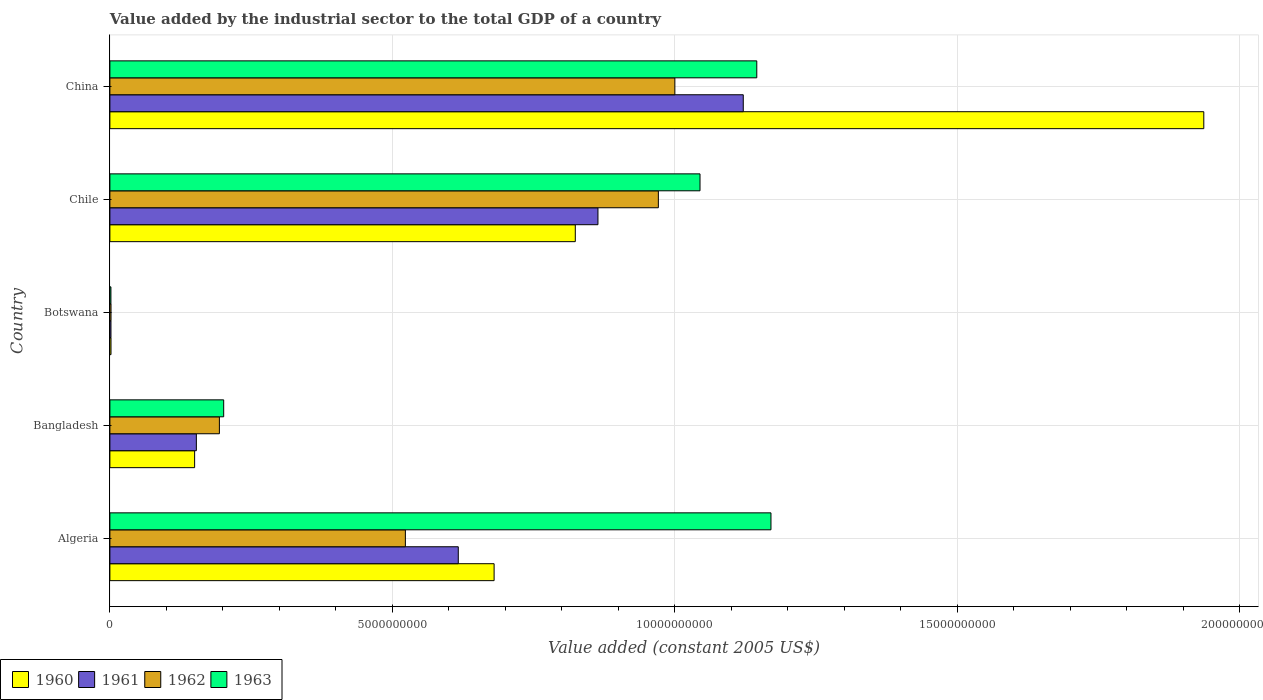How many different coloured bars are there?
Your answer should be compact. 4. Are the number of bars per tick equal to the number of legend labels?
Make the answer very short. Yes. How many bars are there on the 5th tick from the top?
Provide a succinct answer. 4. What is the label of the 2nd group of bars from the top?
Keep it short and to the point. Chile. What is the value added by the industrial sector in 1962 in Chile?
Provide a short and direct response. 9.71e+09. Across all countries, what is the maximum value added by the industrial sector in 1960?
Your response must be concise. 1.94e+1. Across all countries, what is the minimum value added by the industrial sector in 1963?
Make the answer very short. 1.83e+07. In which country was the value added by the industrial sector in 1961 maximum?
Make the answer very short. China. In which country was the value added by the industrial sector in 1963 minimum?
Your response must be concise. Botswana. What is the total value added by the industrial sector in 1961 in the graph?
Provide a short and direct response. 2.76e+1. What is the difference between the value added by the industrial sector in 1960 in Bangladesh and that in Chile?
Provide a short and direct response. -6.74e+09. What is the difference between the value added by the industrial sector in 1961 in Bangladesh and the value added by the industrial sector in 1963 in Chile?
Provide a succinct answer. -8.92e+09. What is the average value added by the industrial sector in 1963 per country?
Ensure brevity in your answer.  7.13e+09. What is the difference between the value added by the industrial sector in 1961 and value added by the industrial sector in 1960 in Algeria?
Your response must be concise. -6.34e+08. In how many countries, is the value added by the industrial sector in 1962 greater than 15000000000 US$?
Provide a short and direct response. 0. What is the ratio of the value added by the industrial sector in 1962 in Bangladesh to that in Botswana?
Provide a short and direct response. 97.78. Is the difference between the value added by the industrial sector in 1961 in Algeria and Botswana greater than the difference between the value added by the industrial sector in 1960 in Algeria and Botswana?
Provide a succinct answer. No. What is the difference between the highest and the second highest value added by the industrial sector in 1962?
Provide a short and direct response. 2.92e+08. What is the difference between the highest and the lowest value added by the industrial sector in 1962?
Provide a succinct answer. 9.98e+09. Is it the case that in every country, the sum of the value added by the industrial sector in 1961 and value added by the industrial sector in 1960 is greater than the value added by the industrial sector in 1963?
Keep it short and to the point. Yes. How many bars are there?
Your answer should be compact. 20. How many countries are there in the graph?
Make the answer very short. 5. What is the difference between two consecutive major ticks on the X-axis?
Ensure brevity in your answer.  5.00e+09. Does the graph contain any zero values?
Keep it short and to the point. No. Does the graph contain grids?
Ensure brevity in your answer.  Yes. Where does the legend appear in the graph?
Offer a terse response. Bottom left. How many legend labels are there?
Give a very brief answer. 4. What is the title of the graph?
Your response must be concise. Value added by the industrial sector to the total GDP of a country. What is the label or title of the X-axis?
Offer a terse response. Value added (constant 2005 US$). What is the Value added (constant 2005 US$) of 1960 in Algeria?
Keep it short and to the point. 6.80e+09. What is the Value added (constant 2005 US$) in 1961 in Algeria?
Ensure brevity in your answer.  6.17e+09. What is the Value added (constant 2005 US$) in 1962 in Algeria?
Provide a succinct answer. 5.23e+09. What is the Value added (constant 2005 US$) in 1963 in Algeria?
Give a very brief answer. 1.17e+1. What is the Value added (constant 2005 US$) in 1960 in Bangladesh?
Your answer should be compact. 1.50e+09. What is the Value added (constant 2005 US$) of 1961 in Bangladesh?
Provide a succinct answer. 1.53e+09. What is the Value added (constant 2005 US$) in 1962 in Bangladesh?
Make the answer very short. 1.94e+09. What is the Value added (constant 2005 US$) of 1963 in Bangladesh?
Provide a succinct answer. 2.01e+09. What is the Value added (constant 2005 US$) in 1960 in Botswana?
Offer a terse response. 1.96e+07. What is the Value added (constant 2005 US$) of 1961 in Botswana?
Give a very brief answer. 1.92e+07. What is the Value added (constant 2005 US$) of 1962 in Botswana?
Provide a succinct answer. 1.98e+07. What is the Value added (constant 2005 US$) in 1963 in Botswana?
Keep it short and to the point. 1.83e+07. What is the Value added (constant 2005 US$) of 1960 in Chile?
Make the answer very short. 8.24e+09. What is the Value added (constant 2005 US$) in 1961 in Chile?
Make the answer very short. 8.64e+09. What is the Value added (constant 2005 US$) of 1962 in Chile?
Your answer should be compact. 9.71e+09. What is the Value added (constant 2005 US$) in 1963 in Chile?
Offer a terse response. 1.04e+1. What is the Value added (constant 2005 US$) of 1960 in China?
Provide a short and direct response. 1.94e+1. What is the Value added (constant 2005 US$) of 1961 in China?
Your answer should be compact. 1.12e+1. What is the Value added (constant 2005 US$) in 1962 in China?
Provide a succinct answer. 1.00e+1. What is the Value added (constant 2005 US$) of 1963 in China?
Provide a succinct answer. 1.15e+1. Across all countries, what is the maximum Value added (constant 2005 US$) in 1960?
Your answer should be very brief. 1.94e+1. Across all countries, what is the maximum Value added (constant 2005 US$) in 1961?
Keep it short and to the point. 1.12e+1. Across all countries, what is the maximum Value added (constant 2005 US$) in 1962?
Offer a very short reply. 1.00e+1. Across all countries, what is the maximum Value added (constant 2005 US$) in 1963?
Keep it short and to the point. 1.17e+1. Across all countries, what is the minimum Value added (constant 2005 US$) of 1960?
Offer a terse response. 1.96e+07. Across all countries, what is the minimum Value added (constant 2005 US$) of 1961?
Provide a short and direct response. 1.92e+07. Across all countries, what is the minimum Value added (constant 2005 US$) in 1962?
Offer a terse response. 1.98e+07. Across all countries, what is the minimum Value added (constant 2005 US$) of 1963?
Offer a terse response. 1.83e+07. What is the total Value added (constant 2005 US$) of 1960 in the graph?
Your answer should be very brief. 3.59e+1. What is the total Value added (constant 2005 US$) in 1961 in the graph?
Your answer should be very brief. 2.76e+1. What is the total Value added (constant 2005 US$) in 1962 in the graph?
Offer a terse response. 2.69e+1. What is the total Value added (constant 2005 US$) in 1963 in the graph?
Your answer should be compact. 3.56e+1. What is the difference between the Value added (constant 2005 US$) of 1960 in Algeria and that in Bangladesh?
Your answer should be compact. 5.30e+09. What is the difference between the Value added (constant 2005 US$) of 1961 in Algeria and that in Bangladesh?
Give a very brief answer. 4.64e+09. What is the difference between the Value added (constant 2005 US$) of 1962 in Algeria and that in Bangladesh?
Your response must be concise. 3.29e+09. What is the difference between the Value added (constant 2005 US$) of 1963 in Algeria and that in Bangladesh?
Provide a short and direct response. 9.69e+09. What is the difference between the Value added (constant 2005 US$) in 1960 in Algeria and that in Botswana?
Your response must be concise. 6.78e+09. What is the difference between the Value added (constant 2005 US$) of 1961 in Algeria and that in Botswana?
Make the answer very short. 6.15e+09. What is the difference between the Value added (constant 2005 US$) in 1962 in Algeria and that in Botswana?
Offer a very short reply. 5.21e+09. What is the difference between the Value added (constant 2005 US$) of 1963 in Algeria and that in Botswana?
Offer a very short reply. 1.17e+1. What is the difference between the Value added (constant 2005 US$) of 1960 in Algeria and that in Chile?
Provide a succinct answer. -1.44e+09. What is the difference between the Value added (constant 2005 US$) of 1961 in Algeria and that in Chile?
Give a very brief answer. -2.47e+09. What is the difference between the Value added (constant 2005 US$) in 1962 in Algeria and that in Chile?
Give a very brief answer. -4.48e+09. What is the difference between the Value added (constant 2005 US$) in 1963 in Algeria and that in Chile?
Give a very brief answer. 1.26e+09. What is the difference between the Value added (constant 2005 US$) in 1960 in Algeria and that in China?
Offer a very short reply. -1.26e+1. What is the difference between the Value added (constant 2005 US$) in 1961 in Algeria and that in China?
Make the answer very short. -5.05e+09. What is the difference between the Value added (constant 2005 US$) of 1962 in Algeria and that in China?
Provide a succinct answer. -4.77e+09. What is the difference between the Value added (constant 2005 US$) in 1963 in Algeria and that in China?
Give a very brief answer. 2.51e+08. What is the difference between the Value added (constant 2005 US$) of 1960 in Bangladesh and that in Botswana?
Provide a short and direct response. 1.48e+09. What is the difference between the Value added (constant 2005 US$) of 1961 in Bangladesh and that in Botswana?
Offer a terse response. 1.51e+09. What is the difference between the Value added (constant 2005 US$) in 1962 in Bangladesh and that in Botswana?
Give a very brief answer. 1.92e+09. What is the difference between the Value added (constant 2005 US$) in 1963 in Bangladesh and that in Botswana?
Ensure brevity in your answer.  2.00e+09. What is the difference between the Value added (constant 2005 US$) of 1960 in Bangladesh and that in Chile?
Provide a succinct answer. -6.74e+09. What is the difference between the Value added (constant 2005 US$) of 1961 in Bangladesh and that in Chile?
Provide a succinct answer. -7.11e+09. What is the difference between the Value added (constant 2005 US$) of 1962 in Bangladesh and that in Chile?
Your answer should be very brief. -7.77e+09. What is the difference between the Value added (constant 2005 US$) in 1963 in Bangladesh and that in Chile?
Provide a short and direct response. -8.43e+09. What is the difference between the Value added (constant 2005 US$) of 1960 in Bangladesh and that in China?
Provide a short and direct response. -1.79e+1. What is the difference between the Value added (constant 2005 US$) in 1961 in Bangladesh and that in China?
Your answer should be compact. -9.68e+09. What is the difference between the Value added (constant 2005 US$) of 1962 in Bangladesh and that in China?
Keep it short and to the point. -8.06e+09. What is the difference between the Value added (constant 2005 US$) of 1963 in Bangladesh and that in China?
Your answer should be compact. -9.44e+09. What is the difference between the Value added (constant 2005 US$) in 1960 in Botswana and that in Chile?
Provide a short and direct response. -8.22e+09. What is the difference between the Value added (constant 2005 US$) in 1961 in Botswana and that in Chile?
Provide a succinct answer. -8.62e+09. What is the difference between the Value added (constant 2005 US$) in 1962 in Botswana and that in Chile?
Provide a succinct answer. -9.69e+09. What is the difference between the Value added (constant 2005 US$) in 1963 in Botswana and that in Chile?
Your answer should be compact. -1.04e+1. What is the difference between the Value added (constant 2005 US$) in 1960 in Botswana and that in China?
Give a very brief answer. -1.93e+1. What is the difference between the Value added (constant 2005 US$) in 1961 in Botswana and that in China?
Provide a short and direct response. -1.12e+1. What is the difference between the Value added (constant 2005 US$) in 1962 in Botswana and that in China?
Make the answer very short. -9.98e+09. What is the difference between the Value added (constant 2005 US$) in 1963 in Botswana and that in China?
Your response must be concise. -1.14e+1. What is the difference between the Value added (constant 2005 US$) of 1960 in Chile and that in China?
Offer a very short reply. -1.11e+1. What is the difference between the Value added (constant 2005 US$) of 1961 in Chile and that in China?
Your answer should be compact. -2.57e+09. What is the difference between the Value added (constant 2005 US$) in 1962 in Chile and that in China?
Your answer should be very brief. -2.92e+08. What is the difference between the Value added (constant 2005 US$) of 1963 in Chile and that in China?
Offer a very short reply. -1.01e+09. What is the difference between the Value added (constant 2005 US$) of 1960 in Algeria and the Value added (constant 2005 US$) of 1961 in Bangladesh?
Give a very brief answer. 5.27e+09. What is the difference between the Value added (constant 2005 US$) of 1960 in Algeria and the Value added (constant 2005 US$) of 1962 in Bangladesh?
Keep it short and to the point. 4.86e+09. What is the difference between the Value added (constant 2005 US$) of 1960 in Algeria and the Value added (constant 2005 US$) of 1963 in Bangladesh?
Provide a short and direct response. 4.79e+09. What is the difference between the Value added (constant 2005 US$) in 1961 in Algeria and the Value added (constant 2005 US$) in 1962 in Bangladesh?
Provide a short and direct response. 4.23e+09. What is the difference between the Value added (constant 2005 US$) of 1961 in Algeria and the Value added (constant 2005 US$) of 1963 in Bangladesh?
Offer a terse response. 4.15e+09. What is the difference between the Value added (constant 2005 US$) of 1962 in Algeria and the Value added (constant 2005 US$) of 1963 in Bangladesh?
Provide a short and direct response. 3.22e+09. What is the difference between the Value added (constant 2005 US$) of 1960 in Algeria and the Value added (constant 2005 US$) of 1961 in Botswana?
Your response must be concise. 6.78e+09. What is the difference between the Value added (constant 2005 US$) in 1960 in Algeria and the Value added (constant 2005 US$) in 1962 in Botswana?
Your answer should be compact. 6.78e+09. What is the difference between the Value added (constant 2005 US$) of 1960 in Algeria and the Value added (constant 2005 US$) of 1963 in Botswana?
Provide a succinct answer. 6.78e+09. What is the difference between the Value added (constant 2005 US$) in 1961 in Algeria and the Value added (constant 2005 US$) in 1962 in Botswana?
Make the answer very short. 6.15e+09. What is the difference between the Value added (constant 2005 US$) in 1961 in Algeria and the Value added (constant 2005 US$) in 1963 in Botswana?
Offer a very short reply. 6.15e+09. What is the difference between the Value added (constant 2005 US$) in 1962 in Algeria and the Value added (constant 2005 US$) in 1963 in Botswana?
Provide a short and direct response. 5.21e+09. What is the difference between the Value added (constant 2005 US$) in 1960 in Algeria and the Value added (constant 2005 US$) in 1961 in Chile?
Your answer should be very brief. -1.84e+09. What is the difference between the Value added (constant 2005 US$) of 1960 in Algeria and the Value added (constant 2005 US$) of 1962 in Chile?
Offer a very short reply. -2.91e+09. What is the difference between the Value added (constant 2005 US$) of 1960 in Algeria and the Value added (constant 2005 US$) of 1963 in Chile?
Your answer should be very brief. -3.65e+09. What is the difference between the Value added (constant 2005 US$) in 1961 in Algeria and the Value added (constant 2005 US$) in 1962 in Chile?
Your answer should be compact. -3.54e+09. What is the difference between the Value added (constant 2005 US$) of 1961 in Algeria and the Value added (constant 2005 US$) of 1963 in Chile?
Give a very brief answer. -4.28e+09. What is the difference between the Value added (constant 2005 US$) in 1962 in Algeria and the Value added (constant 2005 US$) in 1963 in Chile?
Provide a short and direct response. -5.22e+09. What is the difference between the Value added (constant 2005 US$) of 1960 in Algeria and the Value added (constant 2005 US$) of 1961 in China?
Provide a short and direct response. -4.41e+09. What is the difference between the Value added (constant 2005 US$) of 1960 in Algeria and the Value added (constant 2005 US$) of 1962 in China?
Ensure brevity in your answer.  -3.20e+09. What is the difference between the Value added (constant 2005 US$) of 1960 in Algeria and the Value added (constant 2005 US$) of 1963 in China?
Provide a succinct answer. -4.65e+09. What is the difference between the Value added (constant 2005 US$) of 1961 in Algeria and the Value added (constant 2005 US$) of 1962 in China?
Your answer should be very brief. -3.83e+09. What is the difference between the Value added (constant 2005 US$) in 1961 in Algeria and the Value added (constant 2005 US$) in 1963 in China?
Offer a very short reply. -5.28e+09. What is the difference between the Value added (constant 2005 US$) of 1962 in Algeria and the Value added (constant 2005 US$) of 1963 in China?
Your answer should be very brief. -6.22e+09. What is the difference between the Value added (constant 2005 US$) in 1960 in Bangladesh and the Value added (constant 2005 US$) in 1961 in Botswana?
Offer a very short reply. 1.48e+09. What is the difference between the Value added (constant 2005 US$) in 1960 in Bangladesh and the Value added (constant 2005 US$) in 1962 in Botswana?
Ensure brevity in your answer.  1.48e+09. What is the difference between the Value added (constant 2005 US$) of 1960 in Bangladesh and the Value added (constant 2005 US$) of 1963 in Botswana?
Make the answer very short. 1.48e+09. What is the difference between the Value added (constant 2005 US$) of 1961 in Bangladesh and the Value added (constant 2005 US$) of 1962 in Botswana?
Your response must be concise. 1.51e+09. What is the difference between the Value added (constant 2005 US$) of 1961 in Bangladesh and the Value added (constant 2005 US$) of 1963 in Botswana?
Keep it short and to the point. 1.51e+09. What is the difference between the Value added (constant 2005 US$) in 1962 in Bangladesh and the Value added (constant 2005 US$) in 1963 in Botswana?
Give a very brief answer. 1.92e+09. What is the difference between the Value added (constant 2005 US$) of 1960 in Bangladesh and the Value added (constant 2005 US$) of 1961 in Chile?
Provide a short and direct response. -7.14e+09. What is the difference between the Value added (constant 2005 US$) in 1960 in Bangladesh and the Value added (constant 2005 US$) in 1962 in Chile?
Your answer should be very brief. -8.21e+09. What is the difference between the Value added (constant 2005 US$) in 1960 in Bangladesh and the Value added (constant 2005 US$) in 1963 in Chile?
Ensure brevity in your answer.  -8.95e+09. What is the difference between the Value added (constant 2005 US$) in 1961 in Bangladesh and the Value added (constant 2005 US$) in 1962 in Chile?
Make the answer very short. -8.18e+09. What is the difference between the Value added (constant 2005 US$) of 1961 in Bangladesh and the Value added (constant 2005 US$) of 1963 in Chile?
Provide a succinct answer. -8.92e+09. What is the difference between the Value added (constant 2005 US$) of 1962 in Bangladesh and the Value added (constant 2005 US$) of 1963 in Chile?
Provide a short and direct response. -8.51e+09. What is the difference between the Value added (constant 2005 US$) in 1960 in Bangladesh and the Value added (constant 2005 US$) in 1961 in China?
Your answer should be very brief. -9.71e+09. What is the difference between the Value added (constant 2005 US$) in 1960 in Bangladesh and the Value added (constant 2005 US$) in 1962 in China?
Your answer should be compact. -8.50e+09. What is the difference between the Value added (constant 2005 US$) in 1960 in Bangladesh and the Value added (constant 2005 US$) in 1963 in China?
Provide a short and direct response. -9.95e+09. What is the difference between the Value added (constant 2005 US$) in 1961 in Bangladesh and the Value added (constant 2005 US$) in 1962 in China?
Your response must be concise. -8.47e+09. What is the difference between the Value added (constant 2005 US$) in 1961 in Bangladesh and the Value added (constant 2005 US$) in 1963 in China?
Offer a terse response. -9.92e+09. What is the difference between the Value added (constant 2005 US$) of 1962 in Bangladesh and the Value added (constant 2005 US$) of 1963 in China?
Your response must be concise. -9.51e+09. What is the difference between the Value added (constant 2005 US$) of 1960 in Botswana and the Value added (constant 2005 US$) of 1961 in Chile?
Provide a succinct answer. -8.62e+09. What is the difference between the Value added (constant 2005 US$) of 1960 in Botswana and the Value added (constant 2005 US$) of 1962 in Chile?
Your response must be concise. -9.69e+09. What is the difference between the Value added (constant 2005 US$) in 1960 in Botswana and the Value added (constant 2005 US$) in 1963 in Chile?
Provide a succinct answer. -1.04e+1. What is the difference between the Value added (constant 2005 US$) of 1961 in Botswana and the Value added (constant 2005 US$) of 1962 in Chile?
Ensure brevity in your answer.  -9.69e+09. What is the difference between the Value added (constant 2005 US$) in 1961 in Botswana and the Value added (constant 2005 US$) in 1963 in Chile?
Offer a very short reply. -1.04e+1. What is the difference between the Value added (constant 2005 US$) of 1962 in Botswana and the Value added (constant 2005 US$) of 1963 in Chile?
Your answer should be compact. -1.04e+1. What is the difference between the Value added (constant 2005 US$) of 1960 in Botswana and the Value added (constant 2005 US$) of 1961 in China?
Provide a short and direct response. -1.12e+1. What is the difference between the Value added (constant 2005 US$) of 1960 in Botswana and the Value added (constant 2005 US$) of 1962 in China?
Ensure brevity in your answer.  -9.98e+09. What is the difference between the Value added (constant 2005 US$) of 1960 in Botswana and the Value added (constant 2005 US$) of 1963 in China?
Give a very brief answer. -1.14e+1. What is the difference between the Value added (constant 2005 US$) of 1961 in Botswana and the Value added (constant 2005 US$) of 1962 in China?
Ensure brevity in your answer.  -9.98e+09. What is the difference between the Value added (constant 2005 US$) in 1961 in Botswana and the Value added (constant 2005 US$) in 1963 in China?
Ensure brevity in your answer.  -1.14e+1. What is the difference between the Value added (constant 2005 US$) in 1962 in Botswana and the Value added (constant 2005 US$) in 1963 in China?
Ensure brevity in your answer.  -1.14e+1. What is the difference between the Value added (constant 2005 US$) in 1960 in Chile and the Value added (constant 2005 US$) in 1961 in China?
Provide a short and direct response. -2.97e+09. What is the difference between the Value added (constant 2005 US$) of 1960 in Chile and the Value added (constant 2005 US$) of 1962 in China?
Ensure brevity in your answer.  -1.76e+09. What is the difference between the Value added (constant 2005 US$) of 1960 in Chile and the Value added (constant 2005 US$) of 1963 in China?
Keep it short and to the point. -3.21e+09. What is the difference between the Value added (constant 2005 US$) of 1961 in Chile and the Value added (constant 2005 US$) of 1962 in China?
Provide a succinct answer. -1.36e+09. What is the difference between the Value added (constant 2005 US$) of 1961 in Chile and the Value added (constant 2005 US$) of 1963 in China?
Your answer should be compact. -2.81e+09. What is the difference between the Value added (constant 2005 US$) in 1962 in Chile and the Value added (constant 2005 US$) in 1963 in China?
Provide a succinct answer. -1.74e+09. What is the average Value added (constant 2005 US$) in 1960 per country?
Provide a short and direct response. 7.19e+09. What is the average Value added (constant 2005 US$) in 1961 per country?
Give a very brief answer. 5.51e+09. What is the average Value added (constant 2005 US$) in 1962 per country?
Make the answer very short. 5.38e+09. What is the average Value added (constant 2005 US$) in 1963 per country?
Provide a short and direct response. 7.13e+09. What is the difference between the Value added (constant 2005 US$) of 1960 and Value added (constant 2005 US$) of 1961 in Algeria?
Your answer should be very brief. 6.34e+08. What is the difference between the Value added (constant 2005 US$) of 1960 and Value added (constant 2005 US$) of 1962 in Algeria?
Offer a very short reply. 1.57e+09. What is the difference between the Value added (constant 2005 US$) of 1960 and Value added (constant 2005 US$) of 1963 in Algeria?
Your response must be concise. -4.90e+09. What is the difference between the Value added (constant 2005 US$) of 1961 and Value added (constant 2005 US$) of 1962 in Algeria?
Your response must be concise. 9.37e+08. What is the difference between the Value added (constant 2005 US$) in 1961 and Value added (constant 2005 US$) in 1963 in Algeria?
Provide a short and direct response. -5.54e+09. What is the difference between the Value added (constant 2005 US$) in 1962 and Value added (constant 2005 US$) in 1963 in Algeria?
Your answer should be very brief. -6.47e+09. What is the difference between the Value added (constant 2005 US$) of 1960 and Value added (constant 2005 US$) of 1961 in Bangladesh?
Your response must be concise. -3.05e+07. What is the difference between the Value added (constant 2005 US$) of 1960 and Value added (constant 2005 US$) of 1962 in Bangladesh?
Ensure brevity in your answer.  -4.38e+08. What is the difference between the Value added (constant 2005 US$) in 1960 and Value added (constant 2005 US$) in 1963 in Bangladesh?
Offer a very short reply. -5.14e+08. What is the difference between the Value added (constant 2005 US$) in 1961 and Value added (constant 2005 US$) in 1962 in Bangladesh?
Ensure brevity in your answer.  -4.08e+08. What is the difference between the Value added (constant 2005 US$) of 1961 and Value added (constant 2005 US$) of 1963 in Bangladesh?
Ensure brevity in your answer.  -4.84e+08. What is the difference between the Value added (constant 2005 US$) of 1962 and Value added (constant 2005 US$) of 1963 in Bangladesh?
Provide a short and direct response. -7.60e+07. What is the difference between the Value added (constant 2005 US$) in 1960 and Value added (constant 2005 US$) in 1961 in Botswana?
Keep it short and to the point. 4.24e+05. What is the difference between the Value added (constant 2005 US$) of 1960 and Value added (constant 2005 US$) of 1962 in Botswana?
Your answer should be very brief. -2.12e+05. What is the difference between the Value added (constant 2005 US$) in 1960 and Value added (constant 2005 US$) in 1963 in Botswana?
Your answer should be compact. 1.27e+06. What is the difference between the Value added (constant 2005 US$) in 1961 and Value added (constant 2005 US$) in 1962 in Botswana?
Offer a terse response. -6.36e+05. What is the difference between the Value added (constant 2005 US$) in 1961 and Value added (constant 2005 US$) in 1963 in Botswana?
Ensure brevity in your answer.  8.48e+05. What is the difference between the Value added (constant 2005 US$) of 1962 and Value added (constant 2005 US$) of 1963 in Botswana?
Provide a succinct answer. 1.48e+06. What is the difference between the Value added (constant 2005 US$) of 1960 and Value added (constant 2005 US$) of 1961 in Chile?
Provide a succinct answer. -4.01e+08. What is the difference between the Value added (constant 2005 US$) in 1960 and Value added (constant 2005 US$) in 1962 in Chile?
Provide a short and direct response. -1.47e+09. What is the difference between the Value added (constant 2005 US$) in 1960 and Value added (constant 2005 US$) in 1963 in Chile?
Keep it short and to the point. -2.21e+09. What is the difference between the Value added (constant 2005 US$) of 1961 and Value added (constant 2005 US$) of 1962 in Chile?
Make the answer very short. -1.07e+09. What is the difference between the Value added (constant 2005 US$) in 1961 and Value added (constant 2005 US$) in 1963 in Chile?
Offer a very short reply. -1.81e+09. What is the difference between the Value added (constant 2005 US$) in 1962 and Value added (constant 2005 US$) in 1963 in Chile?
Your answer should be compact. -7.37e+08. What is the difference between the Value added (constant 2005 US$) of 1960 and Value added (constant 2005 US$) of 1961 in China?
Give a very brief answer. 8.15e+09. What is the difference between the Value added (constant 2005 US$) in 1960 and Value added (constant 2005 US$) in 1962 in China?
Keep it short and to the point. 9.36e+09. What is the difference between the Value added (constant 2005 US$) in 1960 and Value added (constant 2005 US$) in 1963 in China?
Your answer should be compact. 7.91e+09. What is the difference between the Value added (constant 2005 US$) in 1961 and Value added (constant 2005 US$) in 1962 in China?
Ensure brevity in your answer.  1.21e+09. What is the difference between the Value added (constant 2005 US$) of 1961 and Value added (constant 2005 US$) of 1963 in China?
Provide a succinct answer. -2.39e+08. What is the difference between the Value added (constant 2005 US$) of 1962 and Value added (constant 2005 US$) of 1963 in China?
Give a very brief answer. -1.45e+09. What is the ratio of the Value added (constant 2005 US$) in 1960 in Algeria to that in Bangladesh?
Provide a succinct answer. 4.53. What is the ratio of the Value added (constant 2005 US$) of 1961 in Algeria to that in Bangladesh?
Your answer should be compact. 4.03. What is the ratio of the Value added (constant 2005 US$) in 1962 in Algeria to that in Bangladesh?
Make the answer very short. 2.7. What is the ratio of the Value added (constant 2005 US$) in 1963 in Algeria to that in Bangladesh?
Offer a very short reply. 5.81. What is the ratio of the Value added (constant 2005 US$) of 1960 in Algeria to that in Botswana?
Provide a short and direct response. 346.79. What is the ratio of the Value added (constant 2005 US$) of 1961 in Algeria to that in Botswana?
Provide a succinct answer. 321.41. What is the ratio of the Value added (constant 2005 US$) of 1962 in Algeria to that in Botswana?
Offer a terse response. 263.85. What is the ratio of the Value added (constant 2005 US$) of 1963 in Algeria to that in Botswana?
Make the answer very short. 638.08. What is the ratio of the Value added (constant 2005 US$) in 1960 in Algeria to that in Chile?
Make the answer very short. 0.83. What is the ratio of the Value added (constant 2005 US$) of 1961 in Algeria to that in Chile?
Provide a short and direct response. 0.71. What is the ratio of the Value added (constant 2005 US$) in 1962 in Algeria to that in Chile?
Provide a succinct answer. 0.54. What is the ratio of the Value added (constant 2005 US$) in 1963 in Algeria to that in Chile?
Your answer should be very brief. 1.12. What is the ratio of the Value added (constant 2005 US$) of 1960 in Algeria to that in China?
Make the answer very short. 0.35. What is the ratio of the Value added (constant 2005 US$) in 1961 in Algeria to that in China?
Your answer should be very brief. 0.55. What is the ratio of the Value added (constant 2005 US$) in 1962 in Algeria to that in China?
Provide a succinct answer. 0.52. What is the ratio of the Value added (constant 2005 US$) of 1963 in Algeria to that in China?
Provide a succinct answer. 1.02. What is the ratio of the Value added (constant 2005 US$) of 1960 in Bangladesh to that in Botswana?
Your answer should be very brief. 76.48. What is the ratio of the Value added (constant 2005 US$) of 1961 in Bangladesh to that in Botswana?
Make the answer very short. 79.76. What is the ratio of the Value added (constant 2005 US$) of 1962 in Bangladesh to that in Botswana?
Make the answer very short. 97.78. What is the ratio of the Value added (constant 2005 US$) of 1963 in Bangladesh to that in Botswana?
Offer a terse response. 109.83. What is the ratio of the Value added (constant 2005 US$) in 1960 in Bangladesh to that in Chile?
Offer a very short reply. 0.18. What is the ratio of the Value added (constant 2005 US$) in 1961 in Bangladesh to that in Chile?
Make the answer very short. 0.18. What is the ratio of the Value added (constant 2005 US$) in 1962 in Bangladesh to that in Chile?
Keep it short and to the point. 0.2. What is the ratio of the Value added (constant 2005 US$) of 1963 in Bangladesh to that in Chile?
Your response must be concise. 0.19. What is the ratio of the Value added (constant 2005 US$) of 1960 in Bangladesh to that in China?
Your answer should be very brief. 0.08. What is the ratio of the Value added (constant 2005 US$) of 1961 in Bangladesh to that in China?
Make the answer very short. 0.14. What is the ratio of the Value added (constant 2005 US$) in 1962 in Bangladesh to that in China?
Ensure brevity in your answer.  0.19. What is the ratio of the Value added (constant 2005 US$) of 1963 in Bangladesh to that in China?
Provide a short and direct response. 0.18. What is the ratio of the Value added (constant 2005 US$) in 1960 in Botswana to that in Chile?
Provide a short and direct response. 0. What is the ratio of the Value added (constant 2005 US$) of 1961 in Botswana to that in Chile?
Your response must be concise. 0. What is the ratio of the Value added (constant 2005 US$) in 1962 in Botswana to that in Chile?
Your response must be concise. 0. What is the ratio of the Value added (constant 2005 US$) in 1963 in Botswana to that in Chile?
Your answer should be compact. 0. What is the ratio of the Value added (constant 2005 US$) of 1960 in Botswana to that in China?
Give a very brief answer. 0. What is the ratio of the Value added (constant 2005 US$) of 1961 in Botswana to that in China?
Your answer should be very brief. 0. What is the ratio of the Value added (constant 2005 US$) of 1962 in Botswana to that in China?
Offer a terse response. 0. What is the ratio of the Value added (constant 2005 US$) of 1963 in Botswana to that in China?
Your answer should be very brief. 0. What is the ratio of the Value added (constant 2005 US$) in 1960 in Chile to that in China?
Offer a very short reply. 0.43. What is the ratio of the Value added (constant 2005 US$) of 1961 in Chile to that in China?
Offer a very short reply. 0.77. What is the ratio of the Value added (constant 2005 US$) in 1962 in Chile to that in China?
Your answer should be compact. 0.97. What is the ratio of the Value added (constant 2005 US$) in 1963 in Chile to that in China?
Keep it short and to the point. 0.91. What is the difference between the highest and the second highest Value added (constant 2005 US$) of 1960?
Give a very brief answer. 1.11e+1. What is the difference between the highest and the second highest Value added (constant 2005 US$) of 1961?
Provide a succinct answer. 2.57e+09. What is the difference between the highest and the second highest Value added (constant 2005 US$) in 1962?
Keep it short and to the point. 2.92e+08. What is the difference between the highest and the second highest Value added (constant 2005 US$) of 1963?
Provide a succinct answer. 2.51e+08. What is the difference between the highest and the lowest Value added (constant 2005 US$) of 1960?
Your answer should be very brief. 1.93e+1. What is the difference between the highest and the lowest Value added (constant 2005 US$) in 1961?
Make the answer very short. 1.12e+1. What is the difference between the highest and the lowest Value added (constant 2005 US$) of 1962?
Provide a short and direct response. 9.98e+09. What is the difference between the highest and the lowest Value added (constant 2005 US$) in 1963?
Ensure brevity in your answer.  1.17e+1. 